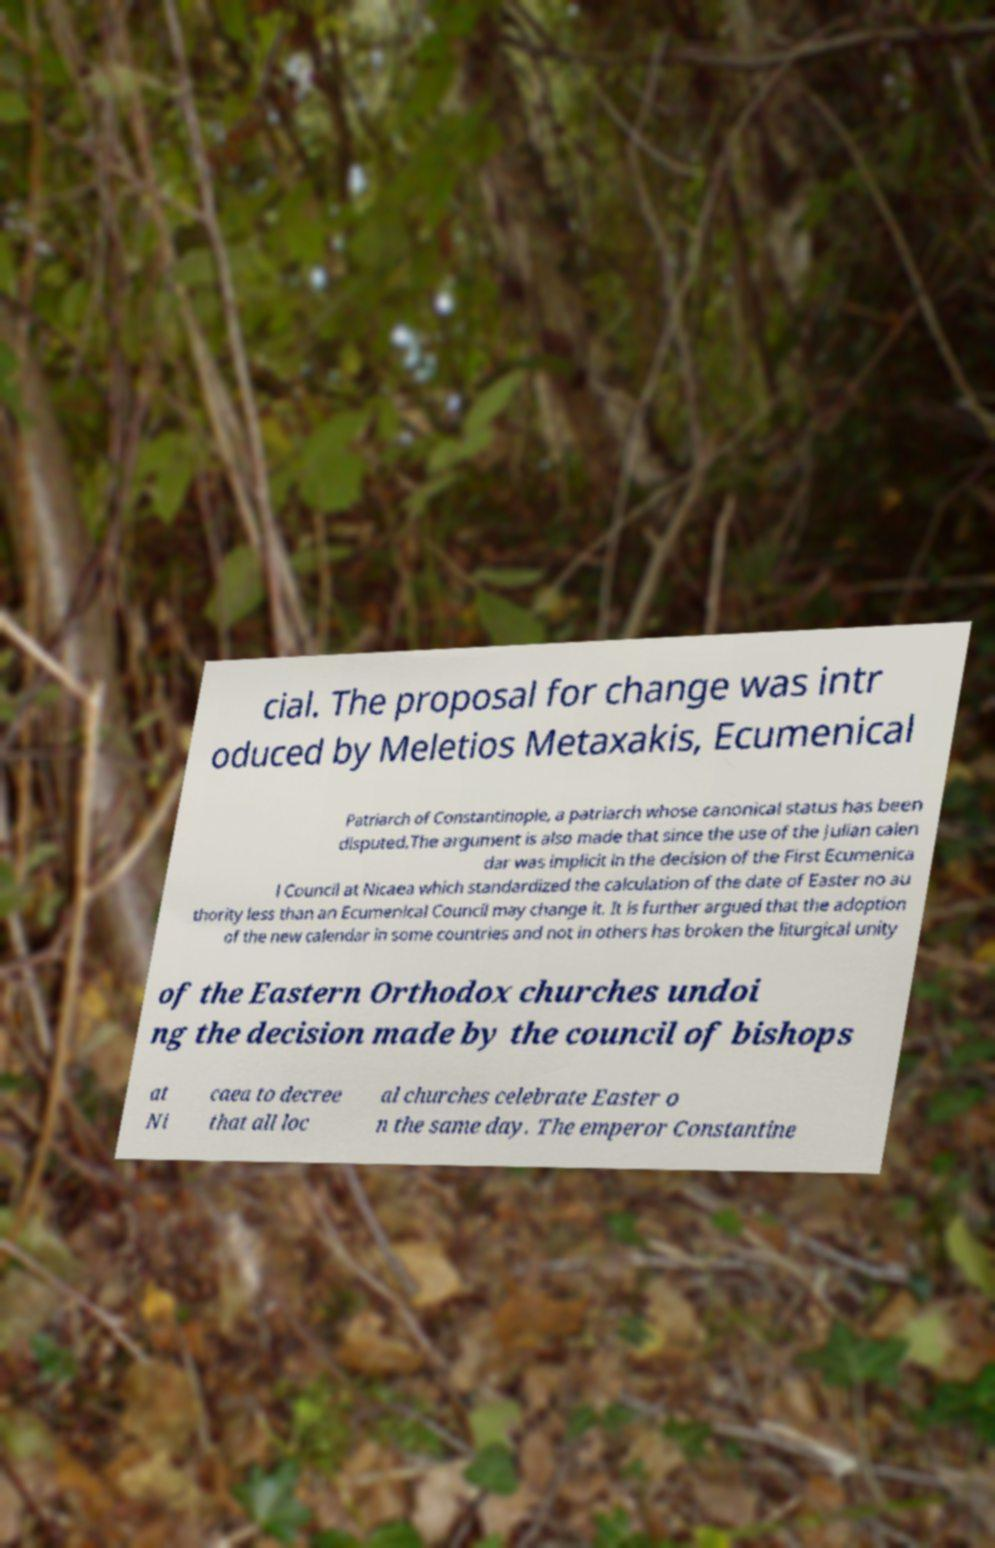Please read and relay the text visible in this image. What does it say? cial. The proposal for change was intr oduced by Meletios Metaxakis, Ecumenical Patriarch of Constantinople, a patriarch whose canonical status has been disputed.The argument is also made that since the use of the Julian calen dar was implicit in the decision of the First Ecumenica l Council at Nicaea which standardized the calculation of the date of Easter no au thority less than an Ecumenical Council may change it. It is further argued that the adoption of the new calendar in some countries and not in others has broken the liturgical unity of the Eastern Orthodox churches undoi ng the decision made by the council of bishops at Ni caea to decree that all loc al churches celebrate Easter o n the same day. The emperor Constantine 